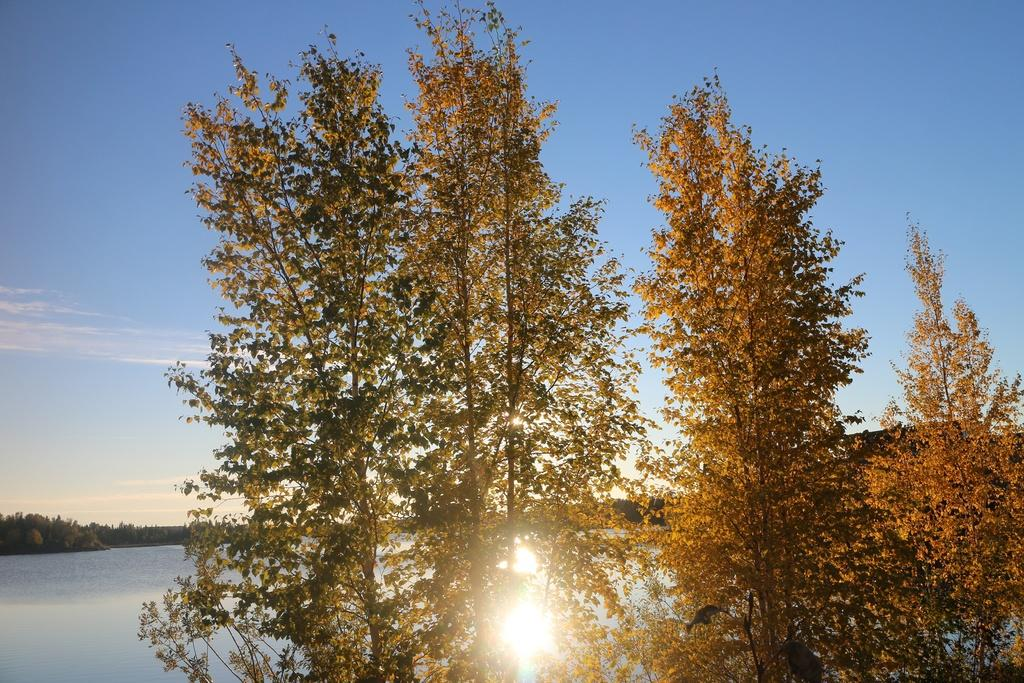What is the condition of the sky in the image? The sky is bright in the image. What natural feature can be seen in the image? There is a river in the image. What type of vegetation is present near the river in the image? Trees are present around the river in the image. Can you hear the grape crying in the image? There is no grape present in the image, and grapes do not have the ability to cry. 